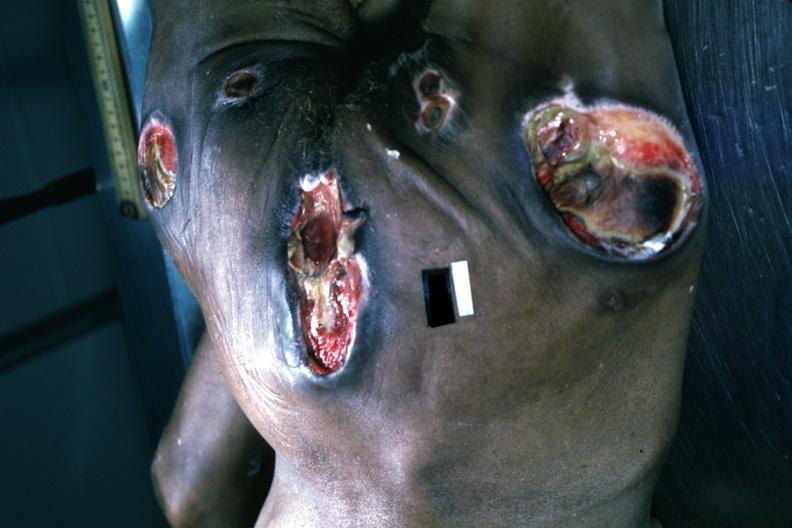what does this image show?
Answer the question using a single word or phrase. Large necrotic ulcers over sacrum buttocks and hips 